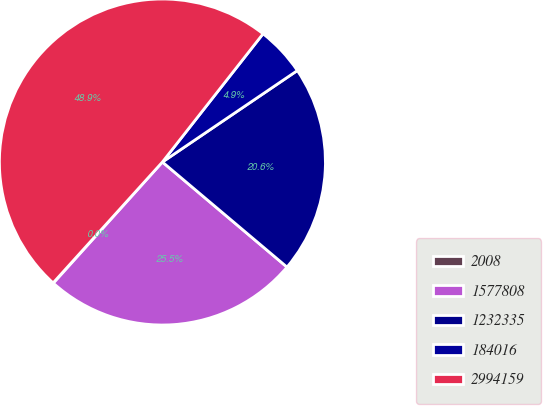<chart> <loc_0><loc_0><loc_500><loc_500><pie_chart><fcel>2008<fcel>1577808<fcel>1232335<fcel>184016<fcel>2994159<nl><fcel>0.04%<fcel>25.51%<fcel>20.63%<fcel>4.93%<fcel>48.89%<nl></chart> 